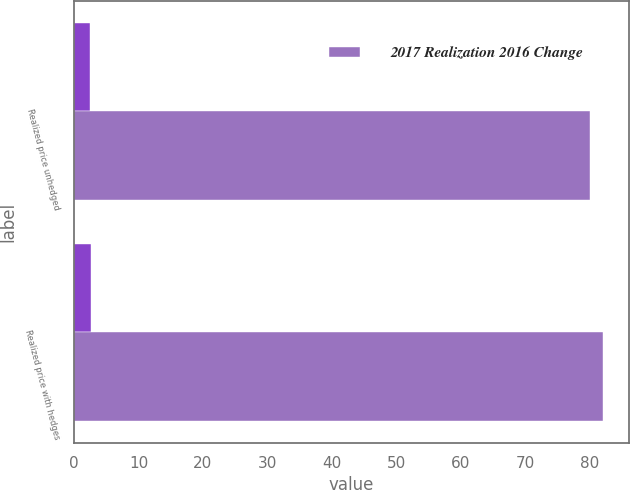Convert chart to OTSL. <chart><loc_0><loc_0><loc_500><loc_500><stacked_bar_chart><ecel><fcel>Realized price unhedged<fcel>Realized price with hedges<nl><fcel>nan<fcel>2.48<fcel>2.56<nl><fcel>2017 Realization 2016 Change<fcel>80<fcel>82<nl></chart> 